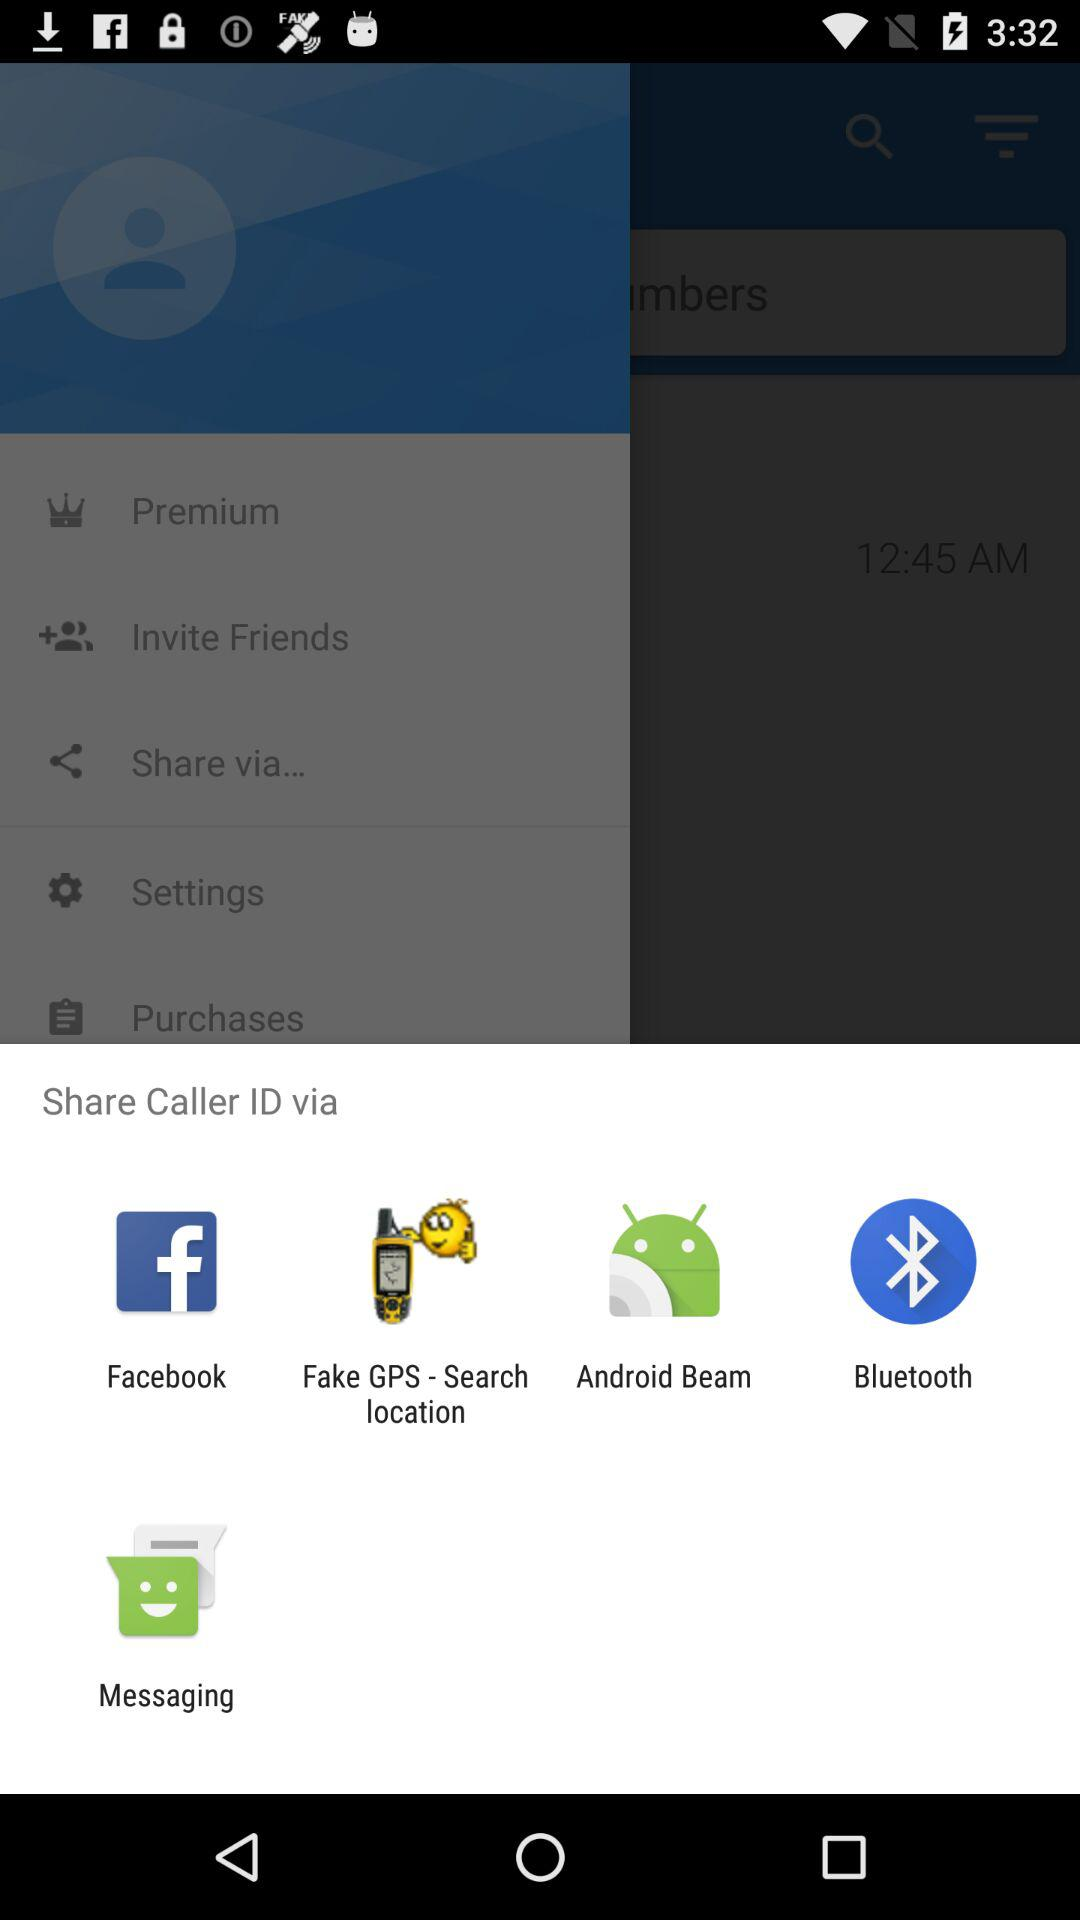What is the user's name?
When the provided information is insufficient, respond with <no answer>. <no answer> 